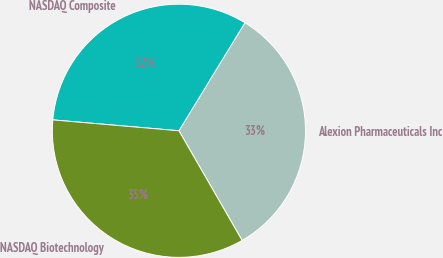Convert chart to OTSL. <chart><loc_0><loc_0><loc_500><loc_500><pie_chart><fcel>Alexion Pharmaceuticals Inc<fcel>NASDAQ Composite<fcel>NASDAQ Biotechnology<nl><fcel>32.95%<fcel>32.36%<fcel>34.69%<nl></chart> 